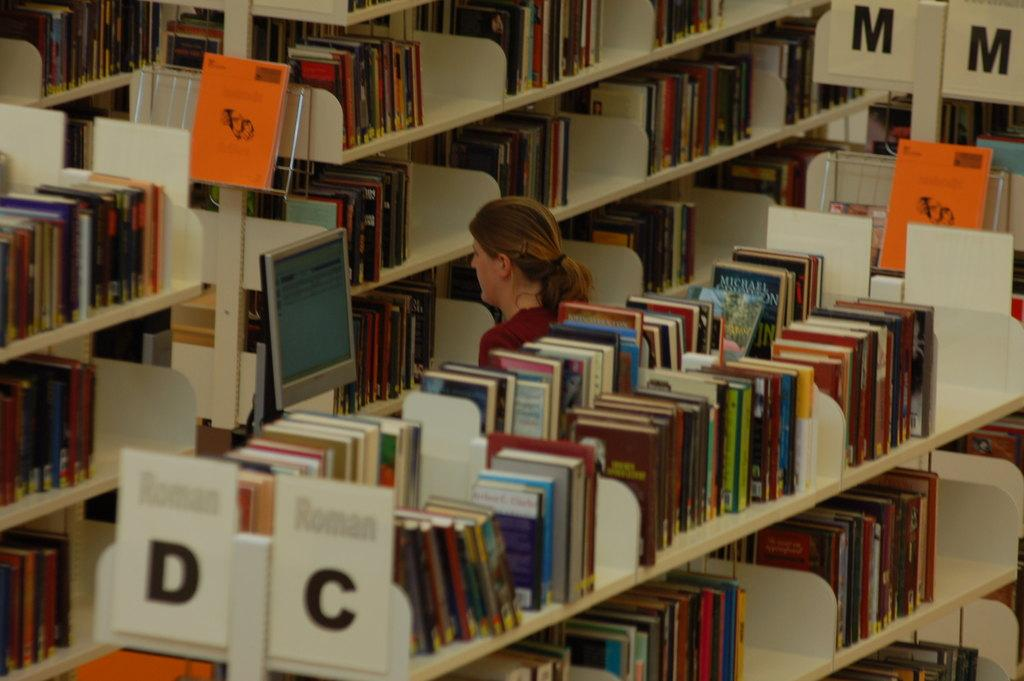<image>
Create a compact narrative representing the image presented. Sections D,C and M are displayed as category signs in this library. 